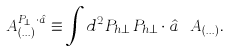Convert formula to latex. <formula><loc_0><loc_0><loc_500><loc_500>A _ { ( \dots ) } ^ { { P } _ { h \perp } \cdot \hat { a } } \equiv \int d ^ { 2 } P _ { h \perp } \, { P } _ { h \perp } \cdot \hat { a } \ A _ { ( \dots ) } .</formula> 